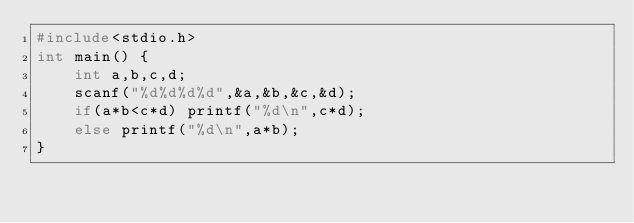Convert code to text. <code><loc_0><loc_0><loc_500><loc_500><_C_>#include<stdio.h>
int main() {
	int a,b,c,d;
	scanf("%d%d%d%d",&a,&b,&c,&d);
	if(a*b<c*d) printf("%d\n",c*d);
	else printf("%d\n",a*b);
}</code> 